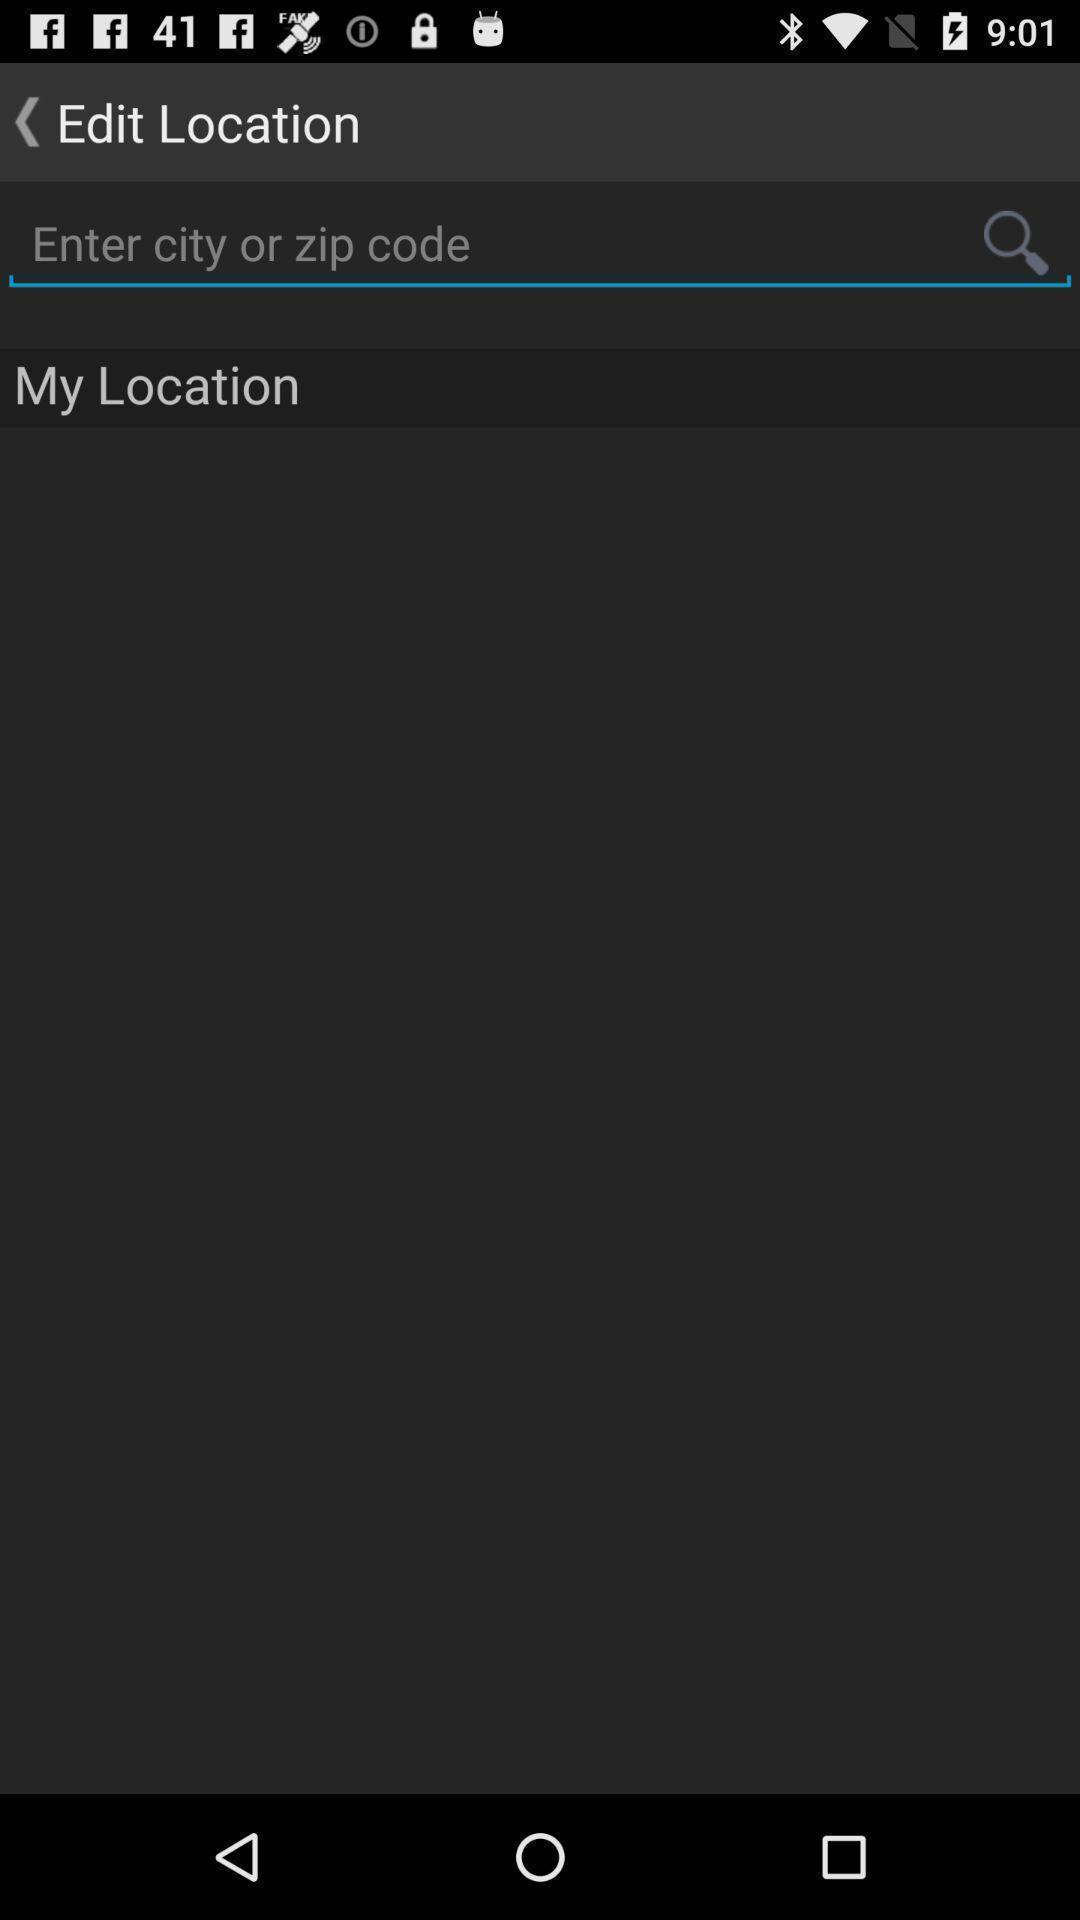Summarize the main components in this picture. Page to edit location in the navigation app. 